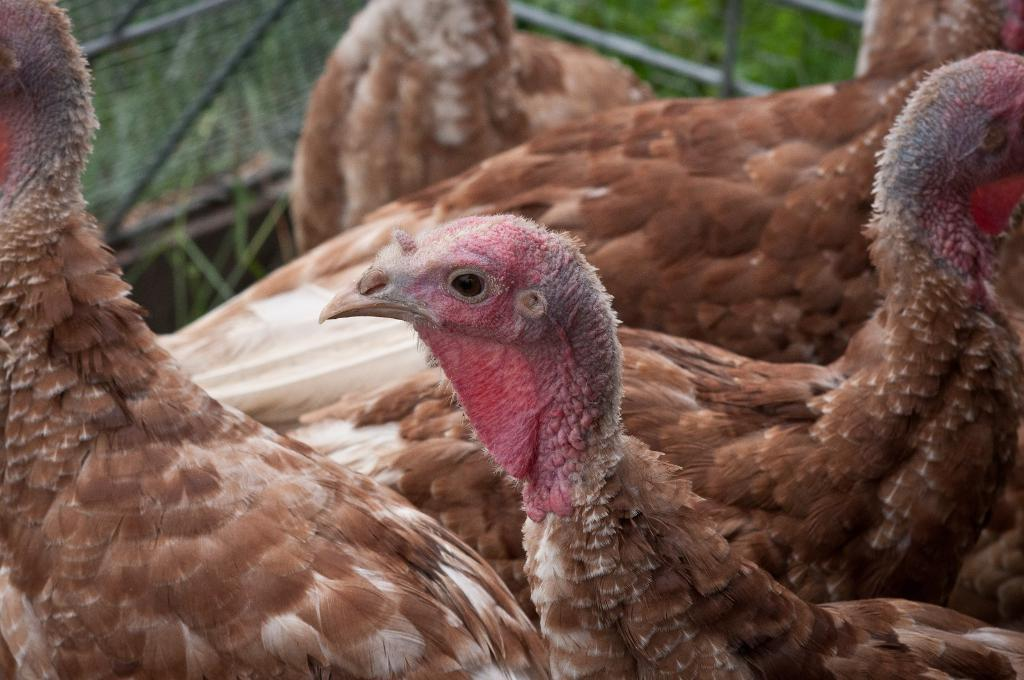What animals are present in the image? There are turkeys in the image. What can be seen in the background of the image? There is a net in the background of the image. What type of vegetation is visible behind the net? There are plants visible behind the net. What type of wax is being used to solve arithmetic problems in the image? There is no wax or arithmetic problems present in the image. What type of plant is shown growing on the turkeys in the image? There are no plants growing on the turkeys in the image; the plants are visible behind the net. 